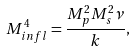Convert formula to latex. <formula><loc_0><loc_0><loc_500><loc_500>M _ { i n f l } ^ { 4 } = \frac { M _ { p } ^ { 2 } M _ { s } ^ { 2 } \nu } { k } ,</formula> 